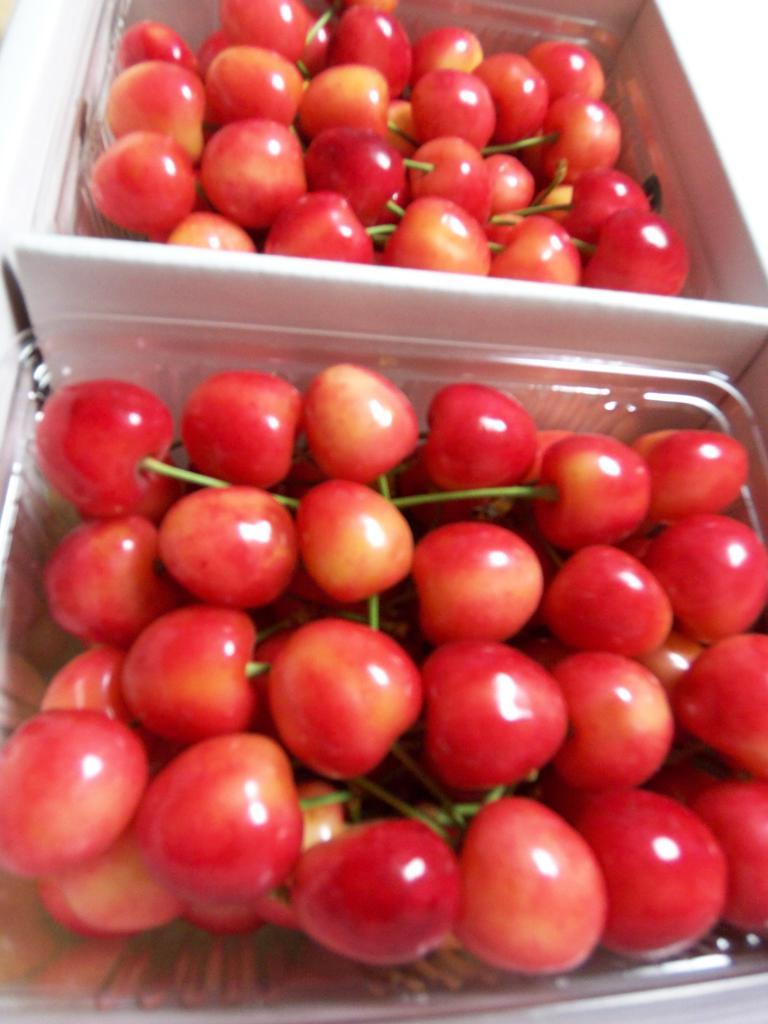How many boxes are visible in the image? There are two boxes in the image. What is inside the boxes? The boxes contain tomatoes. How many quarters are visible in the image? There are no quarters visible in the image. Is there a faucet present in the image? There is no faucet present in the image. 